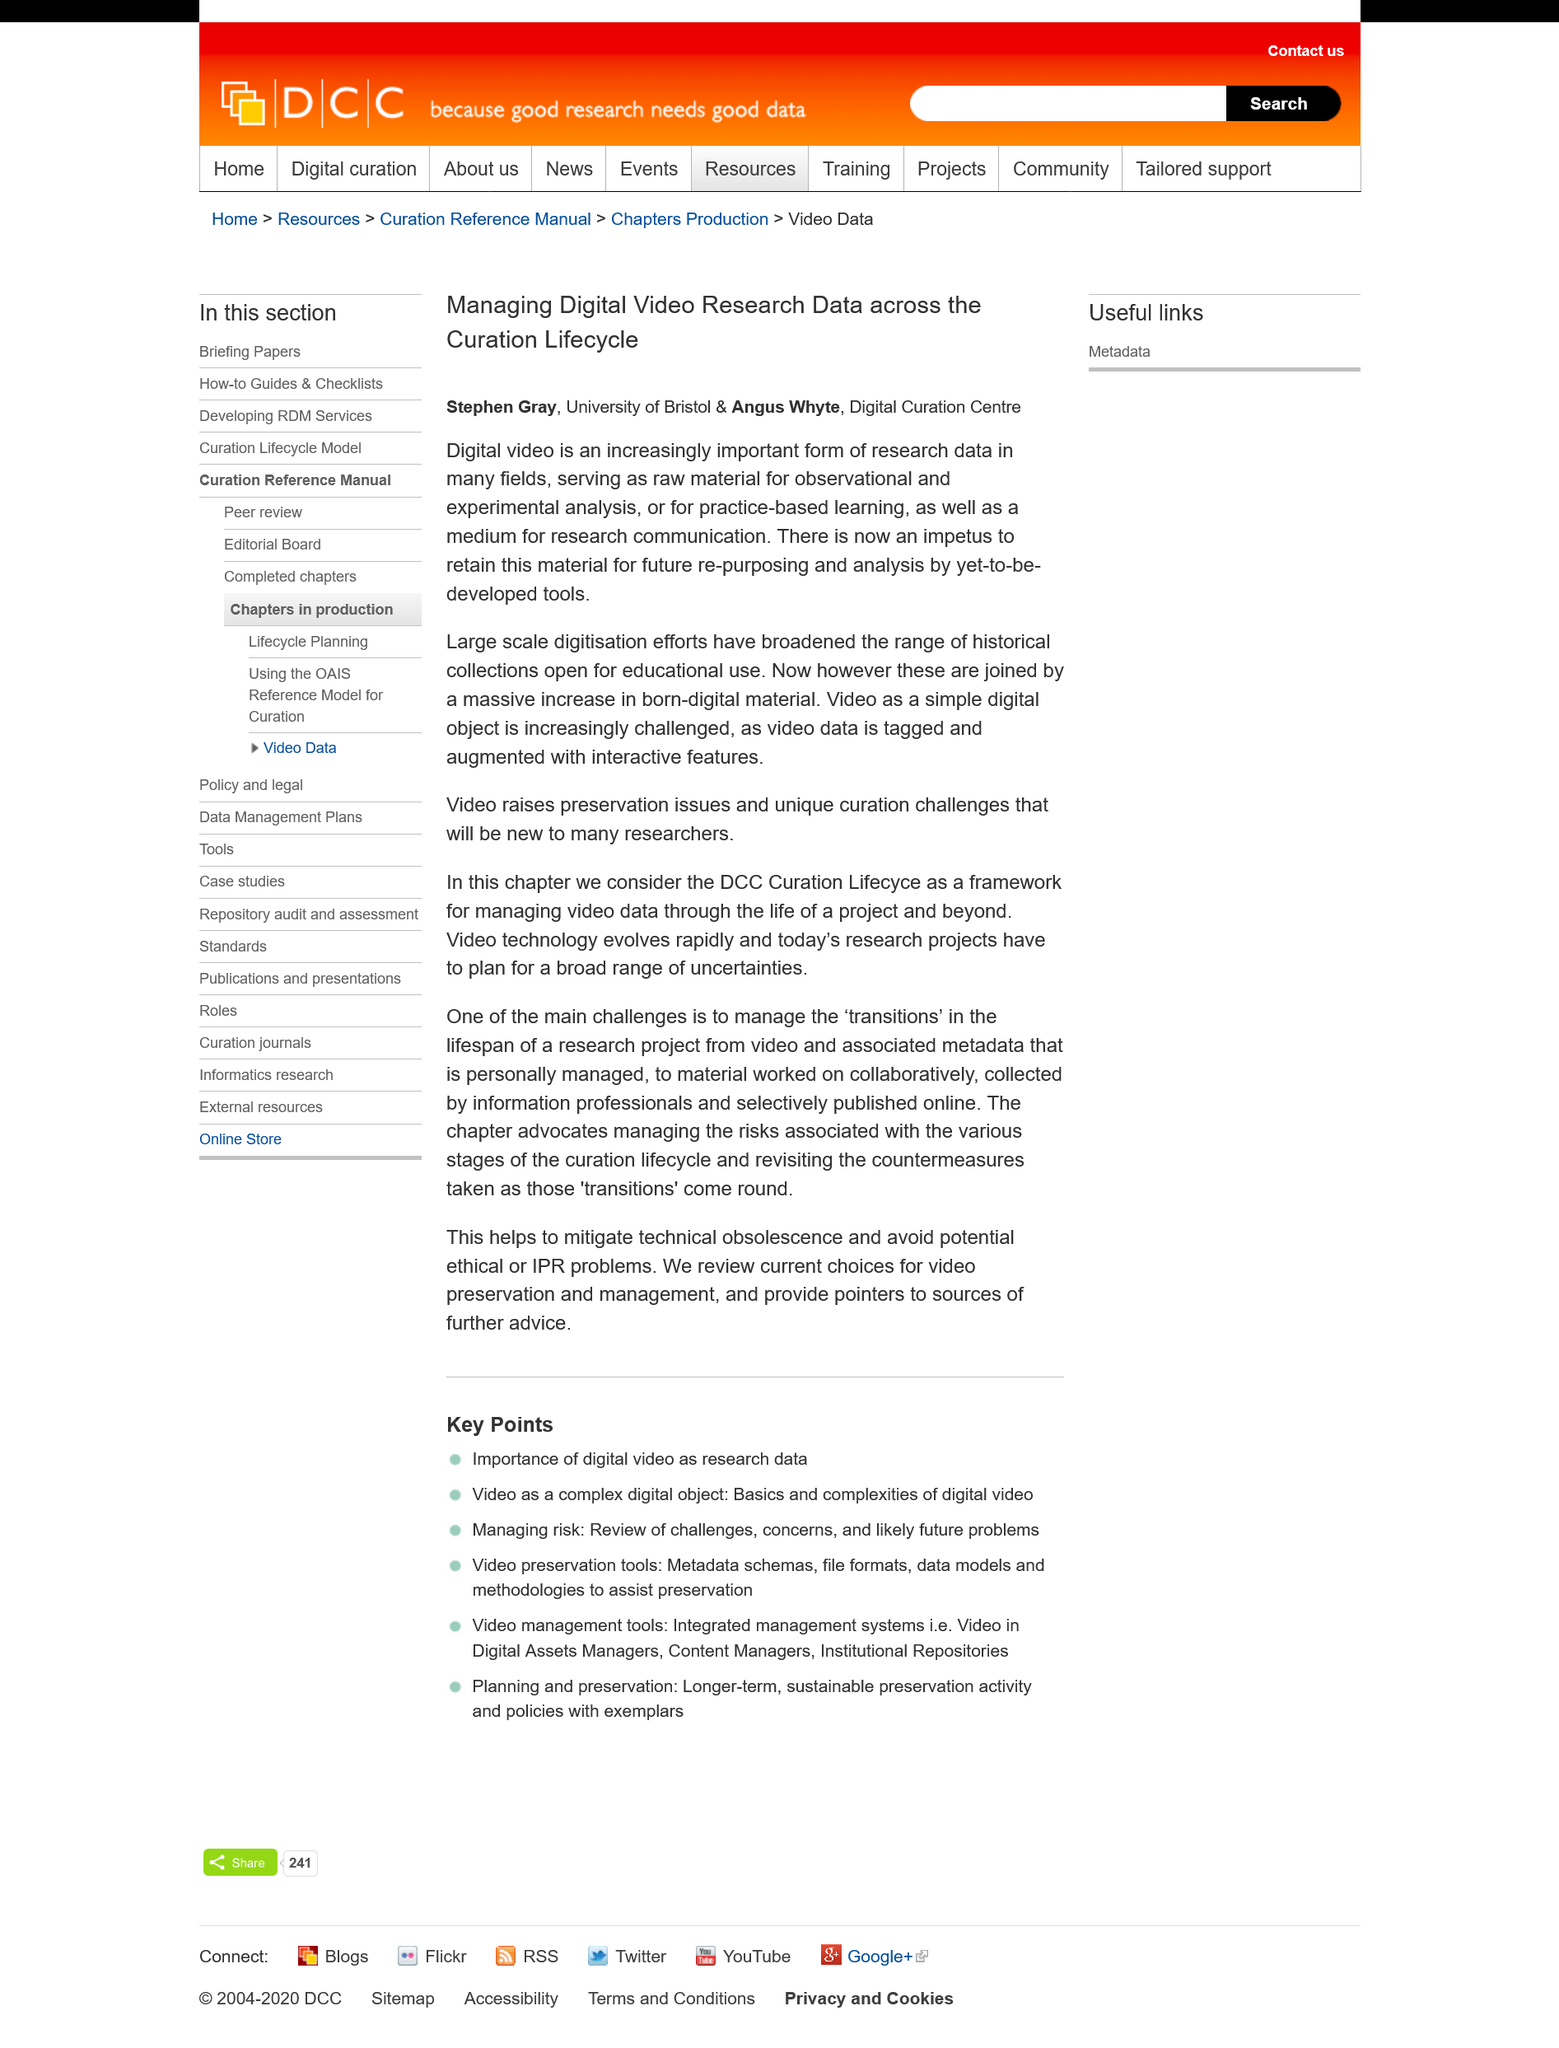Highlight a few significant elements in this photo. Digital video is a critical form of research data because it provides a raw material for observational and experimental analysis in various fields. Large-scale digitization efforts have significantly expanded the scope of historical collections available for educational use, enabling access to a wider range of resources and fostering more comprehensive scholarship. The book "Managing Digital Video Research Data across the Curation Lifecycle" was written by Stephen Gray and Angus Whyte. 